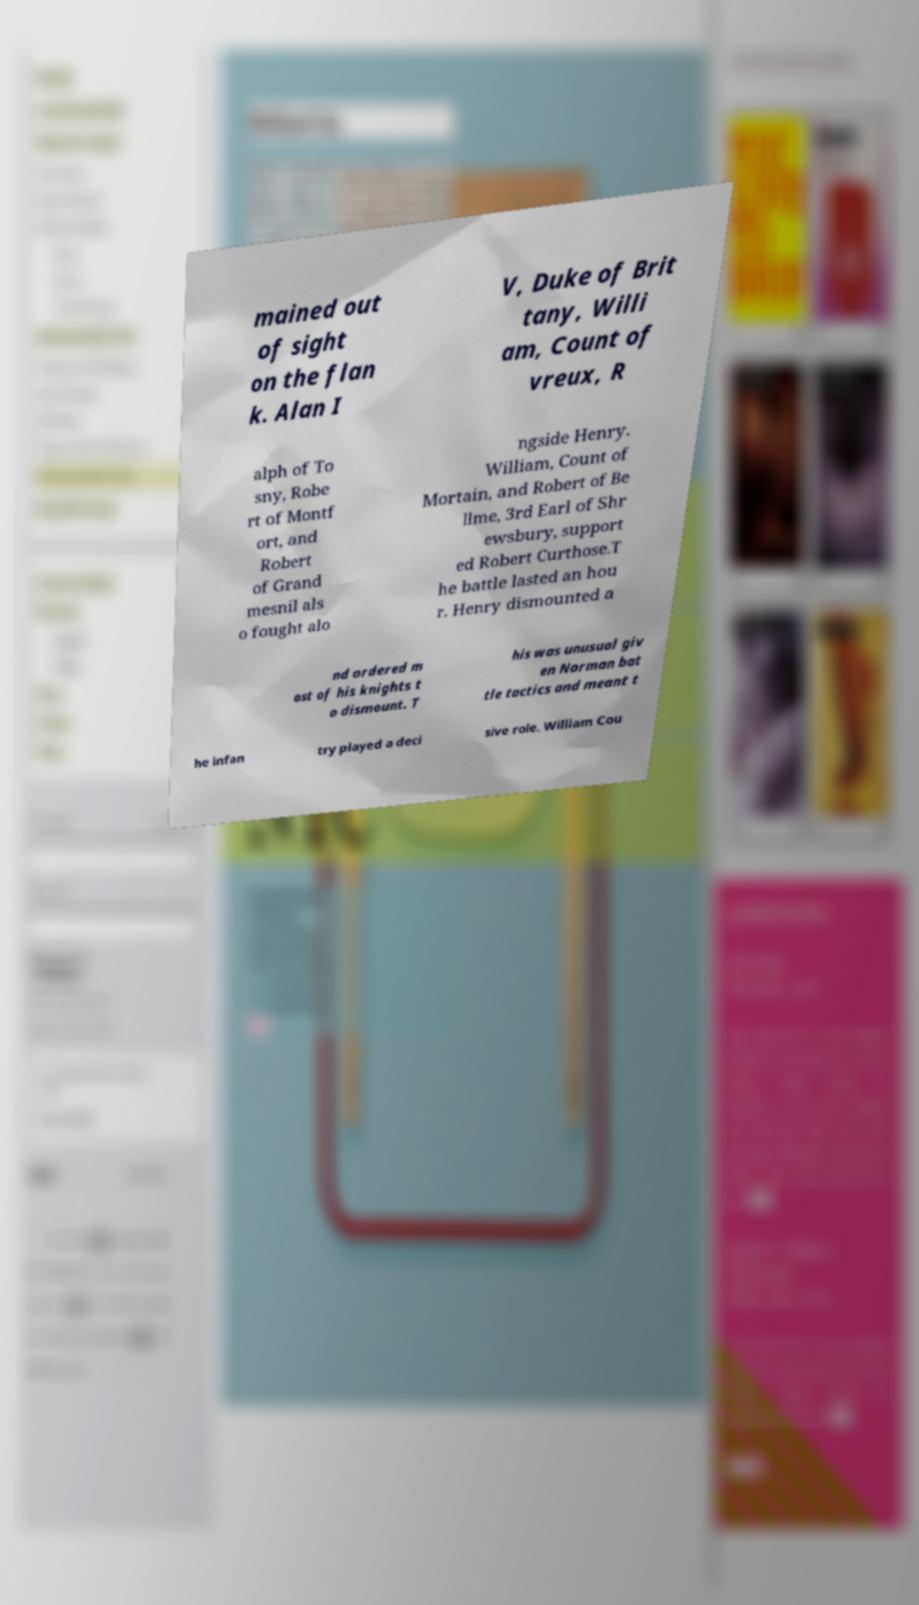Could you assist in decoding the text presented in this image and type it out clearly? mained out of sight on the flan k. Alan I V, Duke of Brit tany, Willi am, Count of vreux, R alph of To sny, Robe rt of Montf ort, and Robert of Grand mesnil als o fought alo ngside Henry. William, Count of Mortain, and Robert of Be llme, 3rd Earl of Shr ewsbury, support ed Robert Curthose.T he battle lasted an hou r. Henry dismounted a nd ordered m ost of his knights t o dismount. T his was unusual giv en Norman bat tle tactics and meant t he infan try played a deci sive role. William Cou 